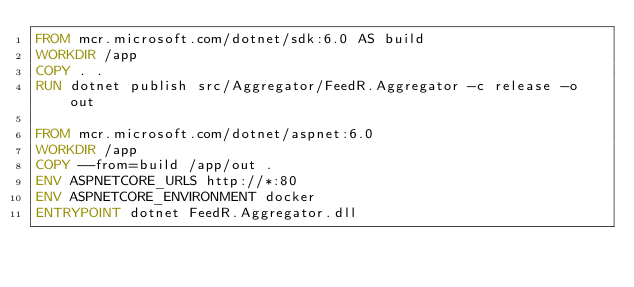Convert code to text. <code><loc_0><loc_0><loc_500><loc_500><_Dockerfile_>FROM mcr.microsoft.com/dotnet/sdk:6.0 AS build
WORKDIR /app
COPY . .
RUN dotnet publish src/Aggregator/FeedR.Aggregator -c release -o out

FROM mcr.microsoft.com/dotnet/aspnet:6.0
WORKDIR /app
COPY --from=build /app/out .
ENV ASPNETCORE_URLS http://*:80
ENV ASPNETCORE_ENVIRONMENT docker
ENTRYPOINT dotnet FeedR.Aggregator.dll</code> 